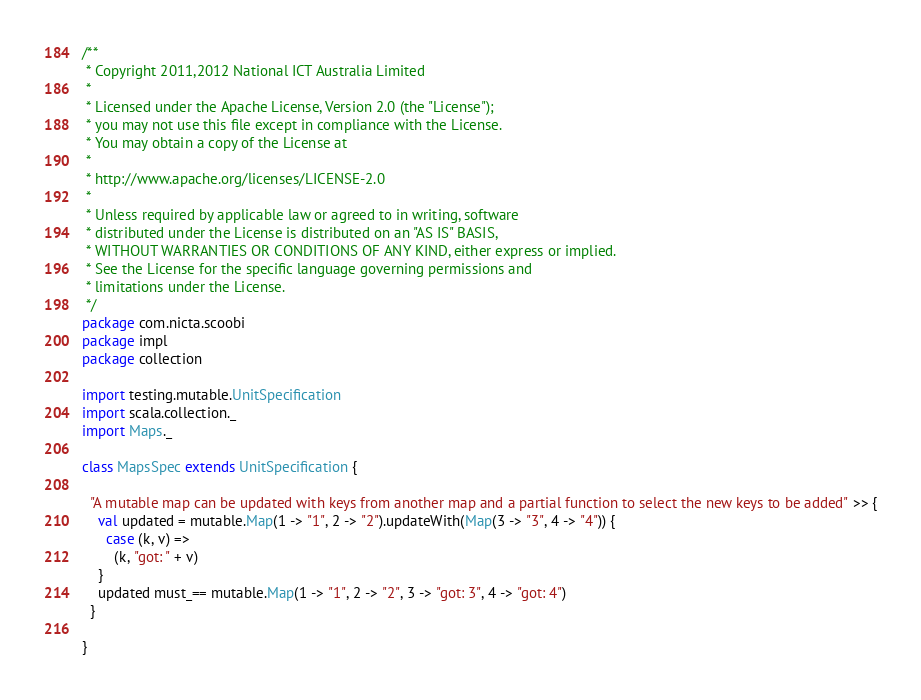<code> <loc_0><loc_0><loc_500><loc_500><_Scala_>/**
 * Copyright 2011,2012 National ICT Australia Limited
 *
 * Licensed under the Apache License, Version 2.0 (the "License");
 * you may not use this file except in compliance with the License.
 * You may obtain a copy of the License at
 *
 * http://www.apache.org/licenses/LICENSE-2.0
 *
 * Unless required by applicable law or agreed to in writing, software
 * distributed under the License is distributed on an "AS IS" BASIS,
 * WITHOUT WARRANTIES OR CONDITIONS OF ANY KIND, either express or implied.
 * See the License for the specific language governing permissions and
 * limitations under the License.
 */
package com.nicta.scoobi
package impl
package collection

import testing.mutable.UnitSpecification
import scala.collection._
import Maps._

class MapsSpec extends UnitSpecification {

  "A mutable map can be updated with keys from another map and a partial function to select the new keys to be added" >> {
    val updated = mutable.Map(1 -> "1", 2 -> "2").updateWith(Map(3 -> "3", 4 -> "4")) {
      case (k, v) =>
        (k, "got: " + v)
    }
    updated must_== mutable.Map(1 -> "1", 2 -> "2", 3 -> "got: 3", 4 -> "got: 4")
  }

}
</code> 